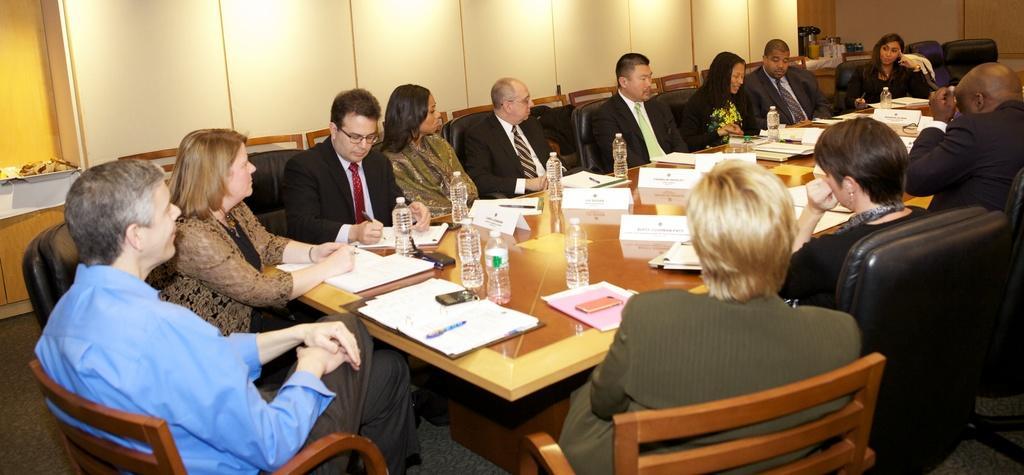Please provide a concise description of this image. There are people sitting around the table. There is a chair. There is a bottle on the table. The man with the red tie is writing on the notes. There are books on the table. There is a mobile placed on the table. 